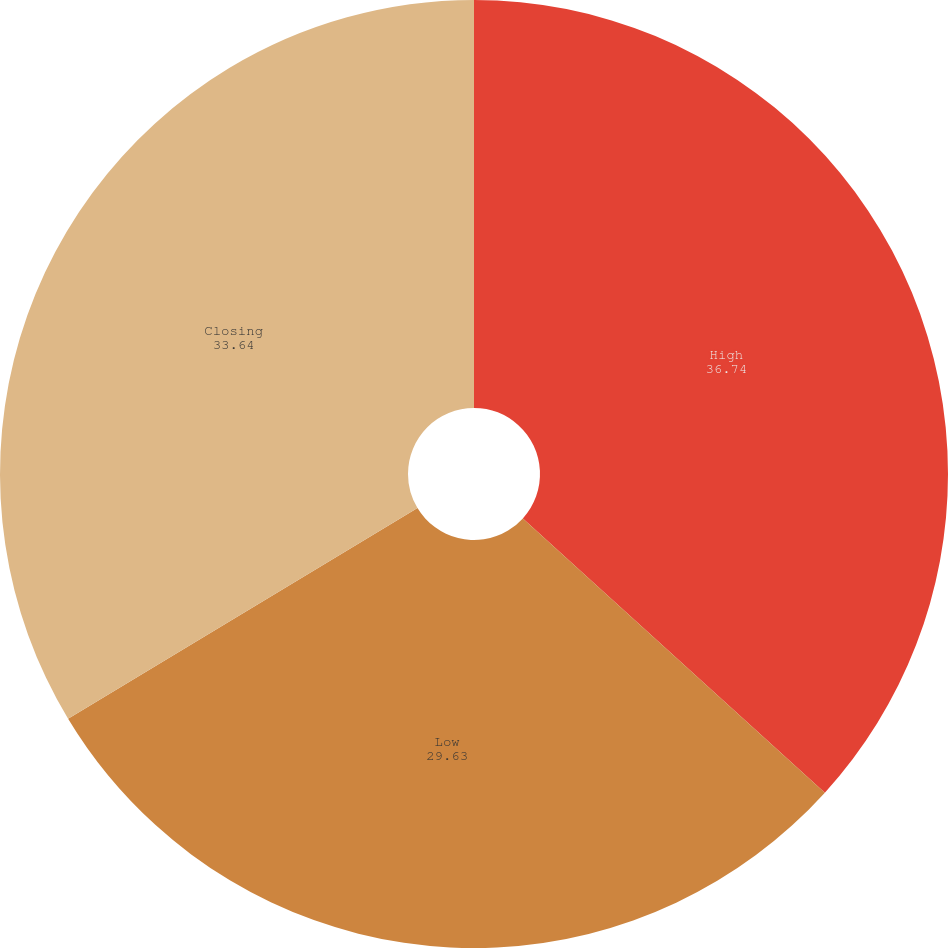Convert chart to OTSL. <chart><loc_0><loc_0><loc_500><loc_500><pie_chart><fcel>High<fcel>Low<fcel>Closing<nl><fcel>36.74%<fcel>29.63%<fcel>33.64%<nl></chart> 